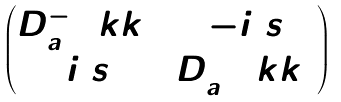<formula> <loc_0><loc_0><loc_500><loc_500>\begin{pmatrix} D _ { a } ^ { - } ( \ k k ) & - i \ s \\ i \ s & D _ { a } ^ { + } ( \ k k ) \end{pmatrix}</formula> 